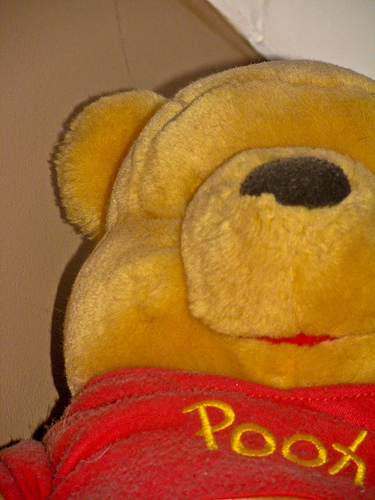<image>
Can you confirm if the pooh is above the floor? Yes. The pooh is positioned above the floor in the vertical space, higher up in the scene. 